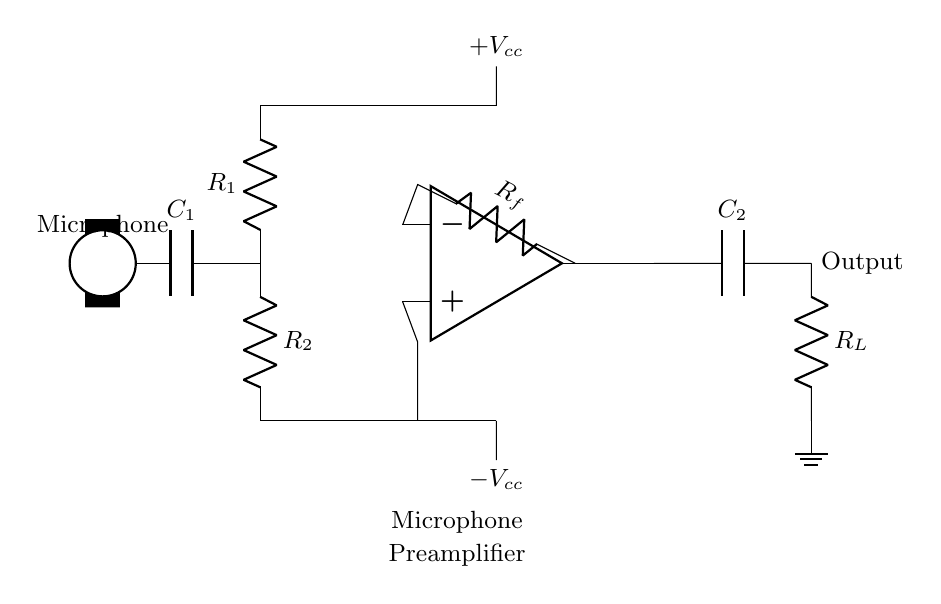What is the purpose of the capacitor labeled C1? The capacitor C1 is used for coupling, allowing AC signals from the microphone to pass through while blocking any DC offset, ensuring only the audio signal is amplified.
Answer: Coupling What do the resistors R1 and R2 form in the circuit? Resistors R1 and R2 form a voltage divider configuration, which helps set the input impedance seen by the microphone and can also help in biasing the operational amplifier input.
Answer: Voltage divider What is the function of the operational amplifier in this circuit? The operational amplifier amplifies the weak audio signal from the microphone, providing a higher signal level suitable for further audio processing or recording.
Answer: Amplification What is the role of capacitor C2 in the circuit? Capacitor C2 acts as a coupling capacitor at the output, allowing the amplified AC audio signal to pass while blocking any DC component, ensuring only the audio signal reaches the load R_L.
Answer: Coupling How many power supply terminals are present in this circuit? There are two power supply terminals in this circuit, marked as positive and negative, which are necessary for the operation of the op-amp.
Answer: Two What is the output from this microphone preamplifier? The output from this microphone preamplifier is a strengthened audio signal, which can then be recorded or further processed.
Answer: Audio signal 